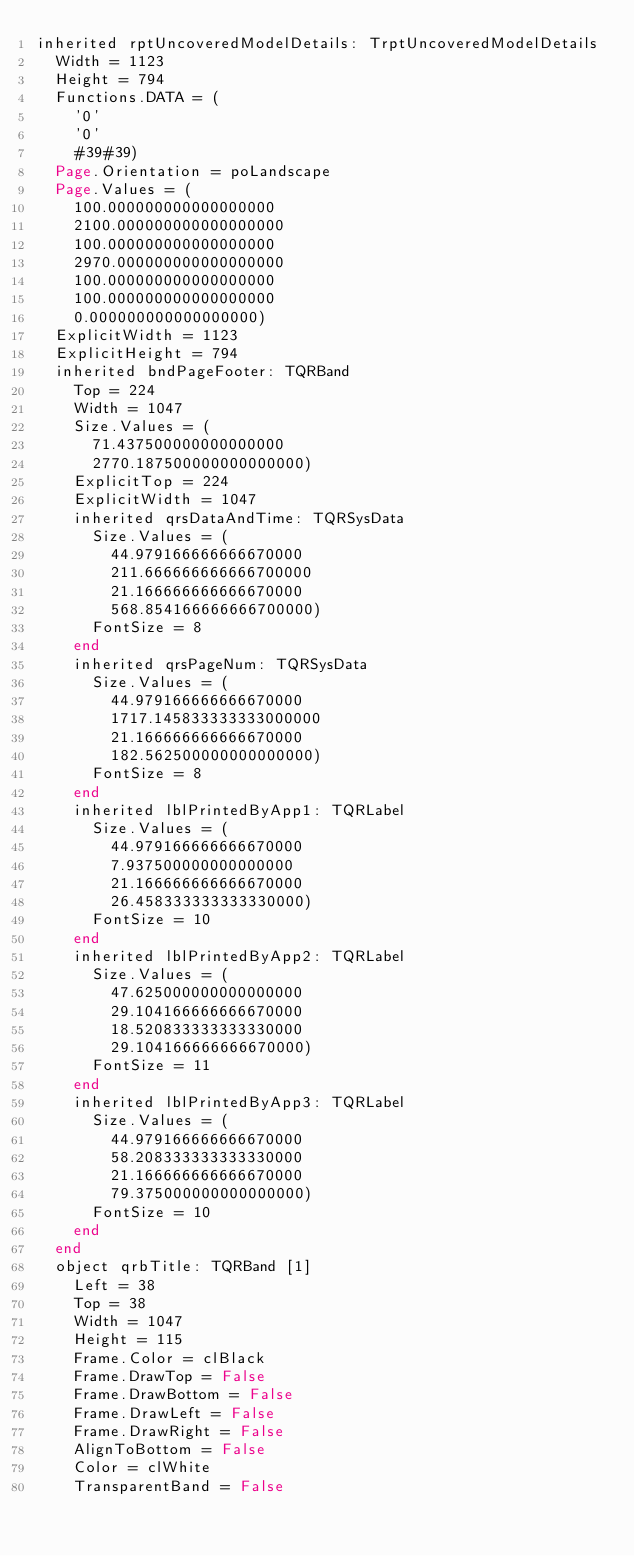<code> <loc_0><loc_0><loc_500><loc_500><_Pascal_>inherited rptUncoveredModelDetails: TrptUncoveredModelDetails
  Width = 1123
  Height = 794
  Functions.DATA = (
    '0'
    '0'
    #39#39)
  Page.Orientation = poLandscape
  Page.Values = (
    100.000000000000000000
    2100.000000000000000000
    100.000000000000000000
    2970.000000000000000000
    100.000000000000000000
    100.000000000000000000
    0.000000000000000000)
  ExplicitWidth = 1123
  ExplicitHeight = 794
  inherited bndPageFooter: TQRBand
    Top = 224
    Width = 1047
    Size.Values = (
      71.437500000000000000
      2770.187500000000000000)
    ExplicitTop = 224
    ExplicitWidth = 1047
    inherited qrsDataAndTime: TQRSysData
      Size.Values = (
        44.979166666666670000
        211.666666666666700000
        21.166666666666670000
        568.854166666666700000)
      FontSize = 8
    end
    inherited qrsPageNum: TQRSysData
      Size.Values = (
        44.979166666666670000
        1717.145833333333000000
        21.166666666666670000
        182.562500000000000000)
      FontSize = 8
    end
    inherited lblPrintedByApp1: TQRLabel
      Size.Values = (
        44.979166666666670000
        7.937500000000000000
        21.166666666666670000
        26.458333333333330000)
      FontSize = 10
    end
    inherited lblPrintedByApp2: TQRLabel
      Size.Values = (
        47.625000000000000000
        29.104166666666670000
        18.520833333333330000
        29.104166666666670000)
      FontSize = 11
    end
    inherited lblPrintedByApp3: TQRLabel
      Size.Values = (
        44.979166666666670000
        58.208333333333330000
        21.166666666666670000
        79.375000000000000000)
      FontSize = 10
    end
  end
  object qrbTitle: TQRBand [1]
    Left = 38
    Top = 38
    Width = 1047
    Height = 115
    Frame.Color = clBlack
    Frame.DrawTop = False
    Frame.DrawBottom = False
    Frame.DrawLeft = False
    Frame.DrawRight = False
    AlignToBottom = False
    Color = clWhite
    TransparentBand = False</code> 